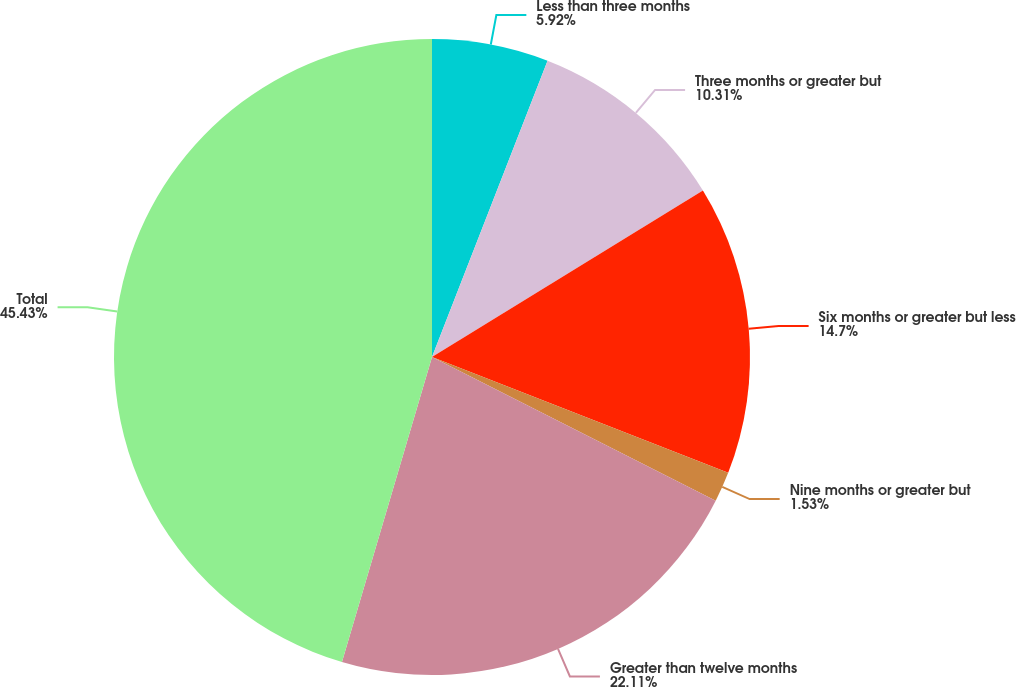Convert chart. <chart><loc_0><loc_0><loc_500><loc_500><pie_chart><fcel>Less than three months<fcel>Three months or greater but<fcel>Six months or greater but less<fcel>Nine months or greater but<fcel>Greater than twelve months<fcel>Total<nl><fcel>5.92%<fcel>10.31%<fcel>14.7%<fcel>1.53%<fcel>22.11%<fcel>45.43%<nl></chart> 